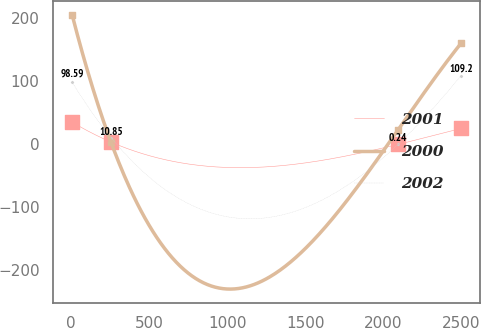Convert chart. <chart><loc_0><loc_0><loc_500><loc_500><line_chart><ecel><fcel>2001<fcel>2000<fcel>2002<nl><fcel>8.52<fcel>35.37<fcel>205.26<fcel>98.59<nl><fcel>257.36<fcel>3.63<fcel>3.12<fcel>10.85<nl><fcel>2094.85<fcel>0.1<fcel>23.33<fcel>0.24<nl><fcel>2496.88<fcel>25.3<fcel>160.41<fcel>109.2<nl></chart> 